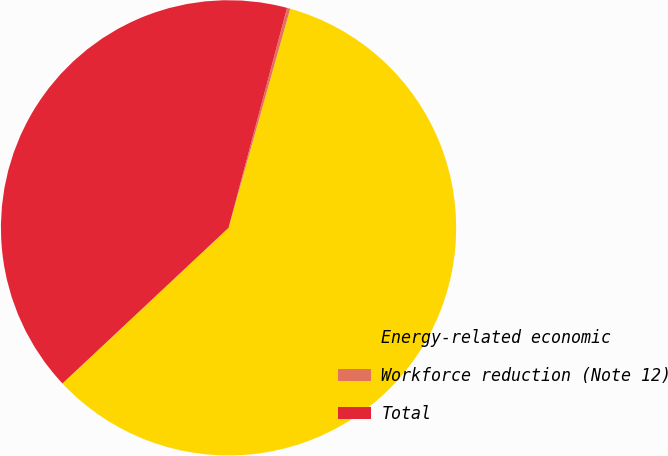Convert chart to OTSL. <chart><loc_0><loc_0><loc_500><loc_500><pie_chart><fcel>Energy-related economic<fcel>Workforce reduction (Note 12)<fcel>Total<nl><fcel>58.64%<fcel>0.23%<fcel>41.12%<nl></chart> 